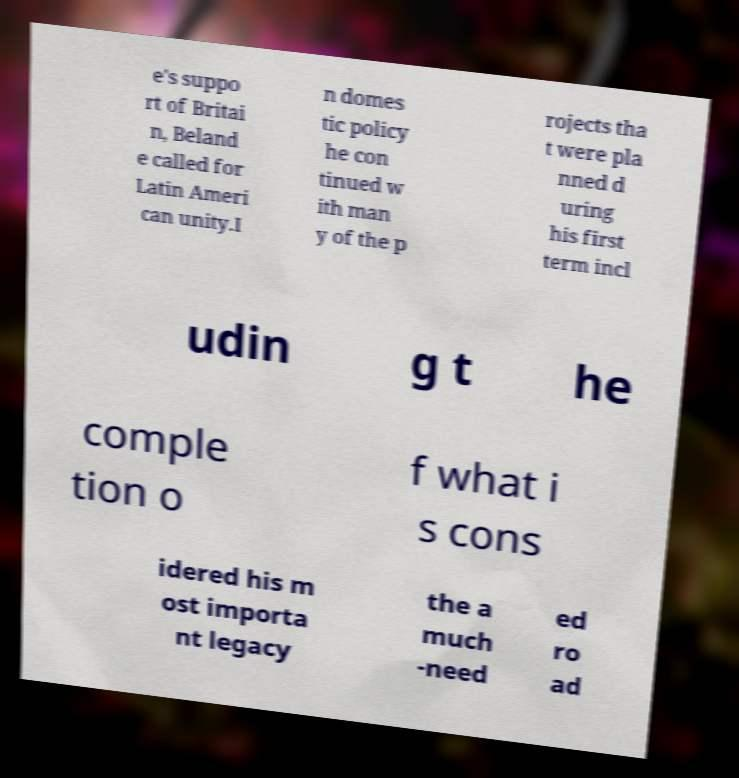Can you read and provide the text displayed in the image?This photo seems to have some interesting text. Can you extract and type it out for me? e's suppo rt of Britai n, Beland e called for Latin Ameri can unity.I n domes tic policy he con tinued w ith man y of the p rojects tha t were pla nned d uring his first term incl udin g t he comple tion o f what i s cons idered his m ost importa nt legacy the a much -need ed ro ad 